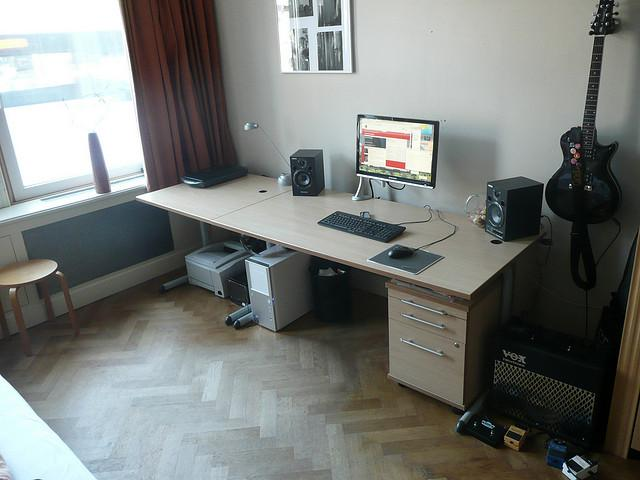What is the device on the floor under the desk near the wall? printer 